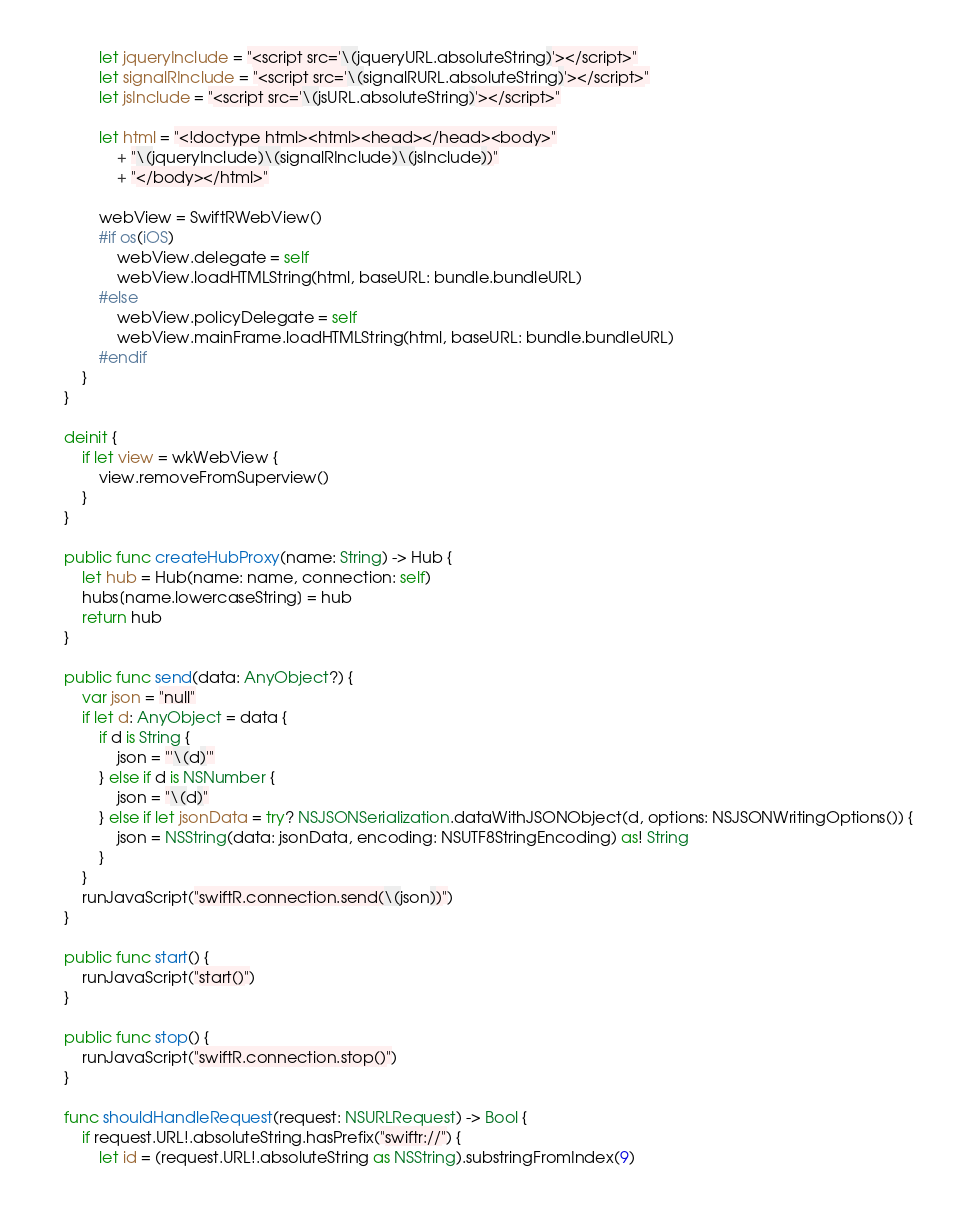Convert code to text. <code><loc_0><loc_0><loc_500><loc_500><_Swift_>            let jqueryInclude = "<script src='\(jqueryURL.absoluteString)'></script>"
            let signalRInclude = "<script src='\(signalRURL.absoluteString)'></script>"
            let jsInclude = "<script src='\(jsURL.absoluteString)'></script>"
            
            let html = "<!doctype html><html><head></head><body>"
                + "\(jqueryInclude)\(signalRInclude)\(jsInclude))"
                + "</body></html>"
            
            webView = SwiftRWebView()
            #if os(iOS)
                webView.delegate = self
                webView.loadHTMLString(html, baseURL: bundle.bundleURL)
            #else
                webView.policyDelegate = self
                webView.mainFrame.loadHTMLString(html, baseURL: bundle.bundleURL)
            #endif
        }
    }
    
    deinit {
        if let view = wkWebView {
            view.removeFromSuperview()
        }
    }
    
    public func createHubProxy(name: String) -> Hub {
        let hub = Hub(name: name, connection: self)
        hubs[name.lowercaseString] = hub
        return hub
    }
    
    public func send(data: AnyObject?) {
        var json = "null"
        if let d: AnyObject = data {
            if d is String {
                json = "'\(d)'"
            } else if d is NSNumber {
                json = "\(d)"
            } else if let jsonData = try? NSJSONSerialization.dataWithJSONObject(d, options: NSJSONWritingOptions()) {
                json = NSString(data: jsonData, encoding: NSUTF8StringEncoding) as! String
            }
        }
        runJavaScript("swiftR.connection.send(\(json))")
    }

    public func start() {
        runJavaScript("start()")
    }
    
    public func stop() {
        runJavaScript("swiftR.connection.stop()")
    }
    
    func shouldHandleRequest(request: NSURLRequest) -> Bool {
        if request.URL!.absoluteString.hasPrefix("swiftr://") {
            let id = (request.URL!.absoluteString as NSString).substringFromIndex(9)</code> 